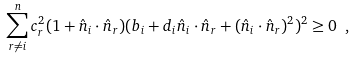<formula> <loc_0><loc_0><loc_500><loc_500>\sum ^ { n } _ { r \not = i } c ^ { 2 } _ { r } ( 1 + \hat { n } _ { i } \cdot \hat { n } _ { r } ) { ( b _ { i } + d _ { i } \hat { n } _ { i } \cdot \hat { n } _ { r } + { ( \hat { n } _ { i } \cdot \hat { n } _ { r } ) ^ { 2 } } ) ^ { 2 } } \geq 0 \ ,</formula> 